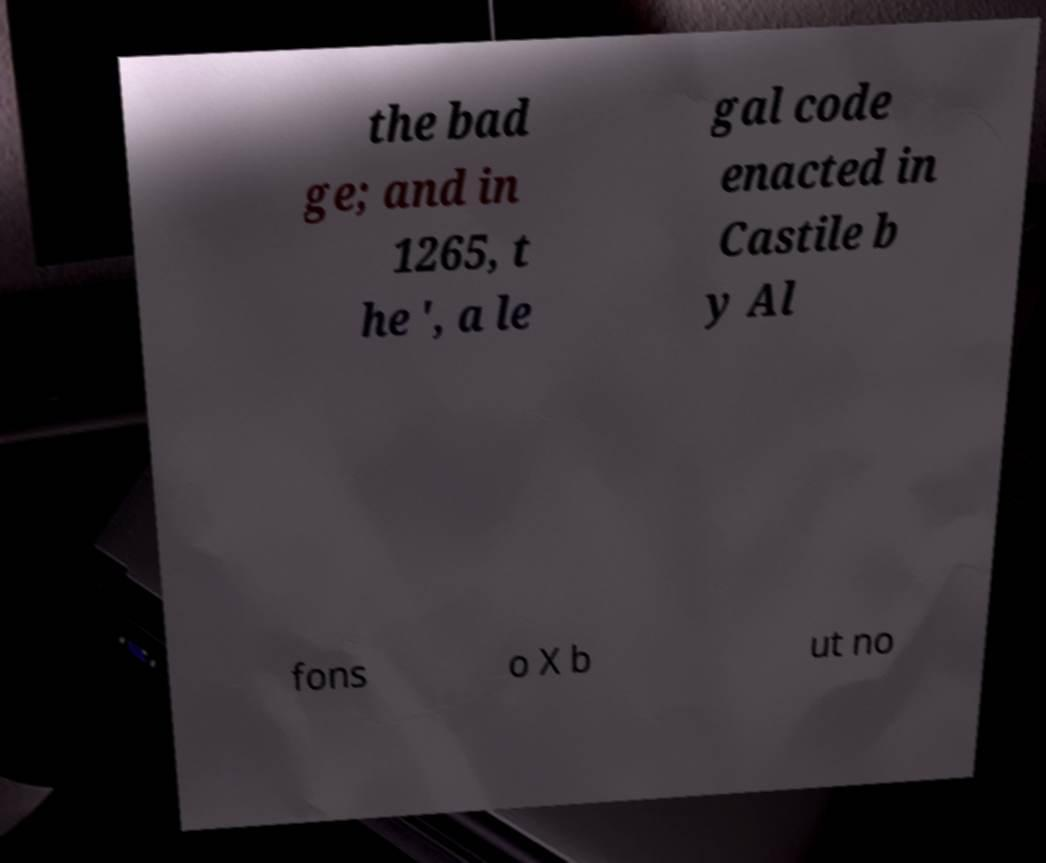Please identify and transcribe the text found in this image. the bad ge; and in 1265, t he ', a le gal code enacted in Castile b y Al fons o X b ut no 